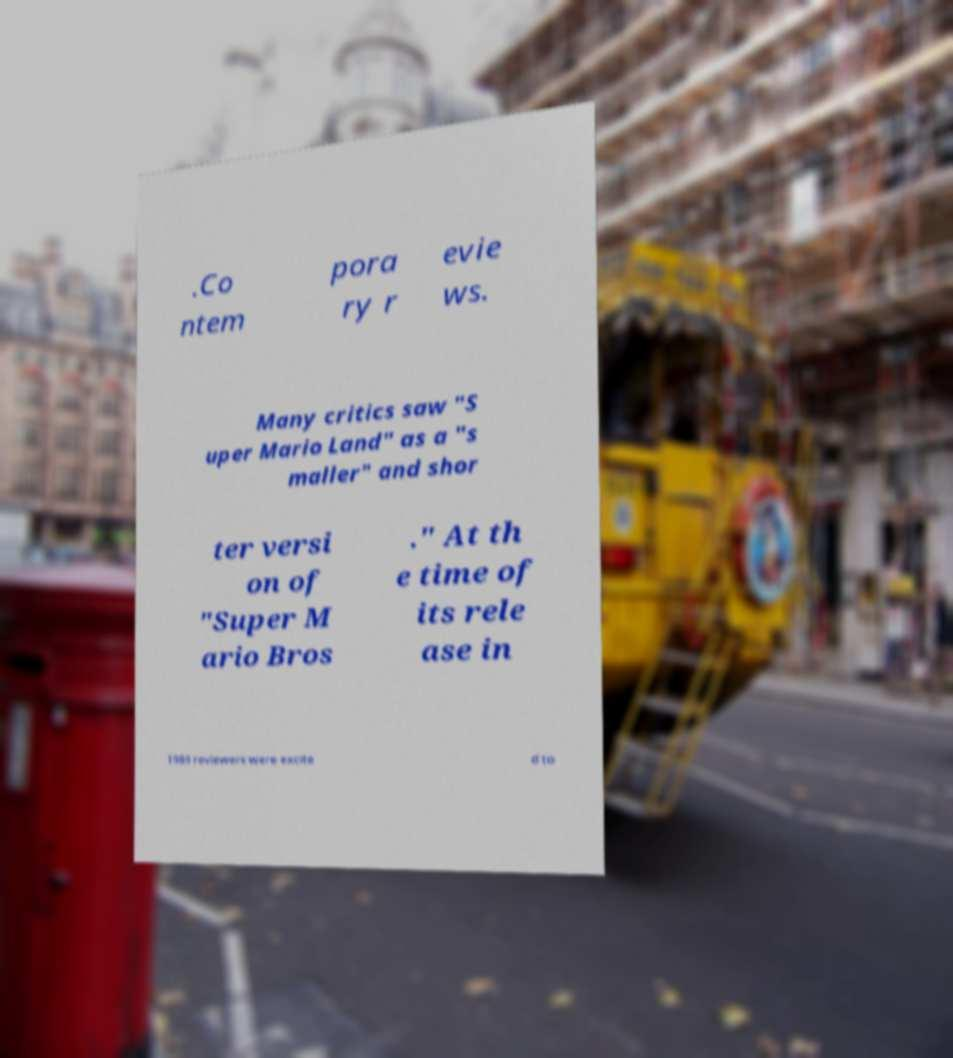There's text embedded in this image that I need extracted. Can you transcribe it verbatim? .Co ntem pora ry r evie ws. Many critics saw "S uper Mario Land" as a "s maller" and shor ter versi on of "Super M ario Bros ." At th e time of its rele ase in 1989 reviewers were excite d to 